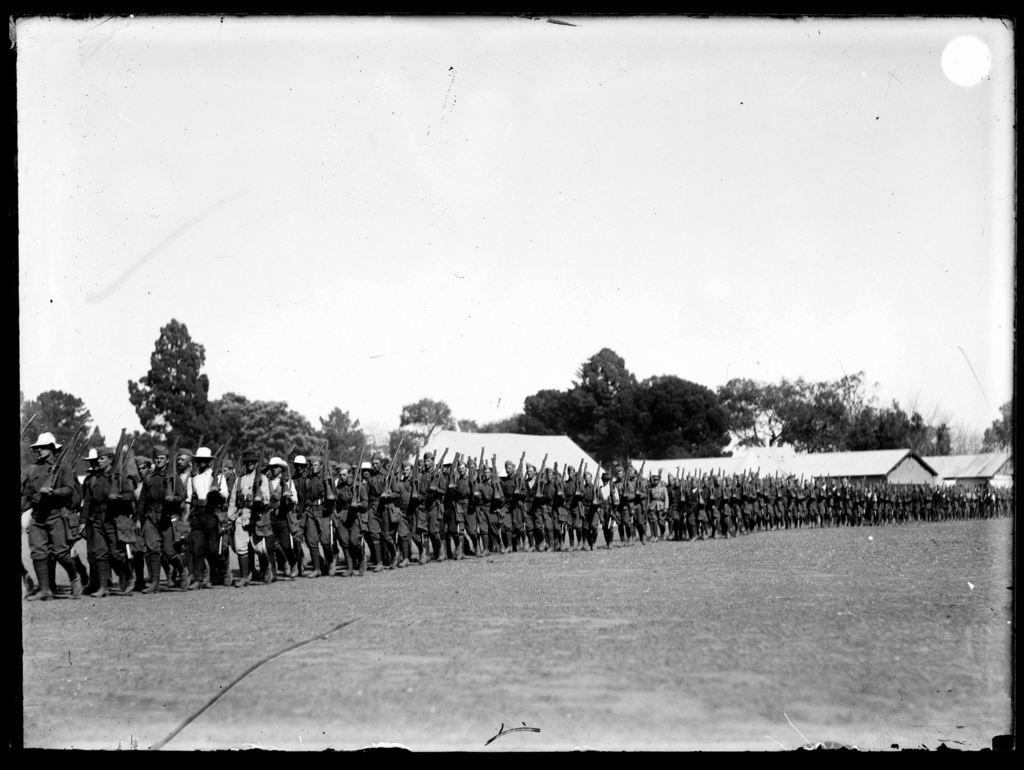What type of pictures are in the image? There are black and white pictures of people walking in the image. What are the people wearing in the pictures? The people are wearing clothes and caps. What are the people holding in their hands? The people are holding rifles in their hands. What type of vegetation can be seen in the image? There are trees visible in the image. What type of structure is in the image? There is a house in the image. What part of the natural environment is visible in the image? The sky is visible in the image. How many planes can be seen in the image? There are no planes visible in the image; the image only contains black and white pictures of people walking, wearing clothes and caps, and holding rifles. 